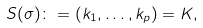Convert formula to latex. <formula><loc_0><loc_0><loc_500><loc_500>S ( \sigma ) \colon = ( k _ { 1 } , \dots , k _ { p } ) = K ,</formula> 